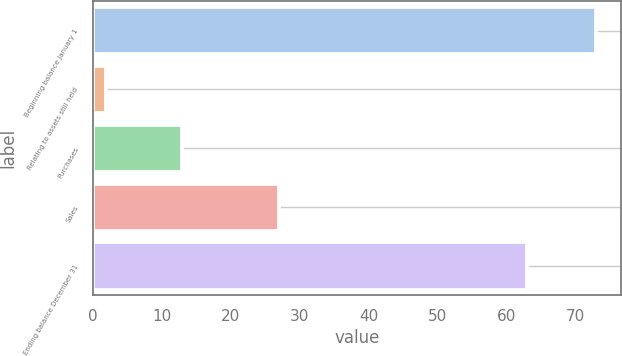Convert chart to OTSL. <chart><loc_0><loc_0><loc_500><loc_500><bar_chart><fcel>Beginning balance January 1<fcel>Relating to assets still held<fcel>Purchases<fcel>Sales<fcel>Ending balance December 31<nl><fcel>73<fcel>2<fcel>13<fcel>27<fcel>63<nl></chart> 